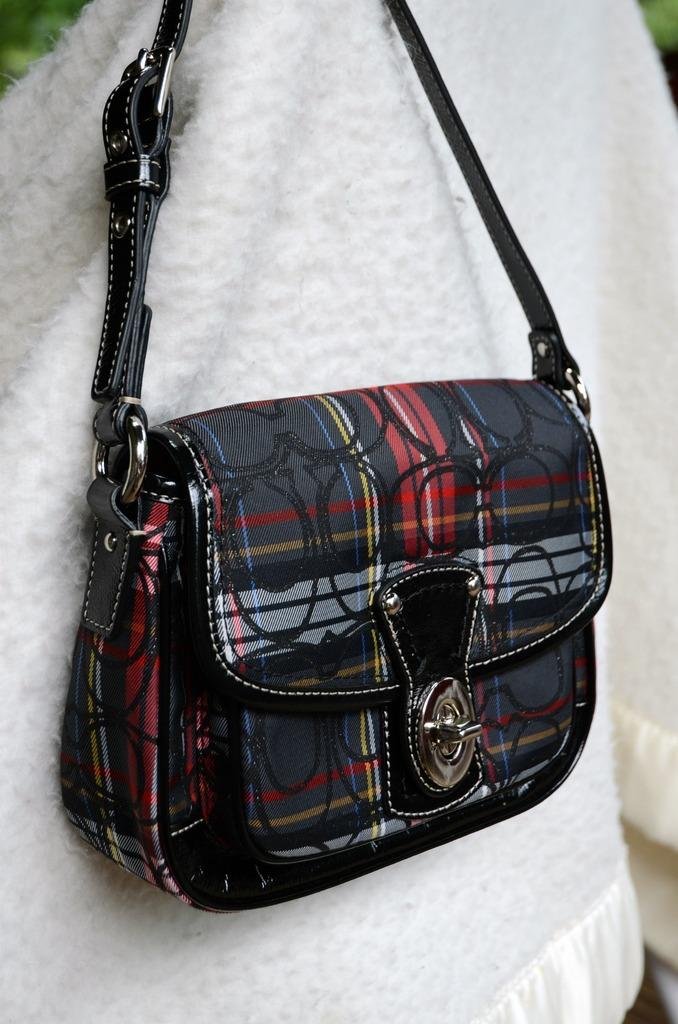What type of bag is in the image? There is a multi-color bag in the image. Where is the bag placed? The bag is placed on a white cloth. What color is the handle of the bag? The handle of the bag is black. Can you see anyone kicking a yard in the image? There is no yard or kicking activity present in the image. 